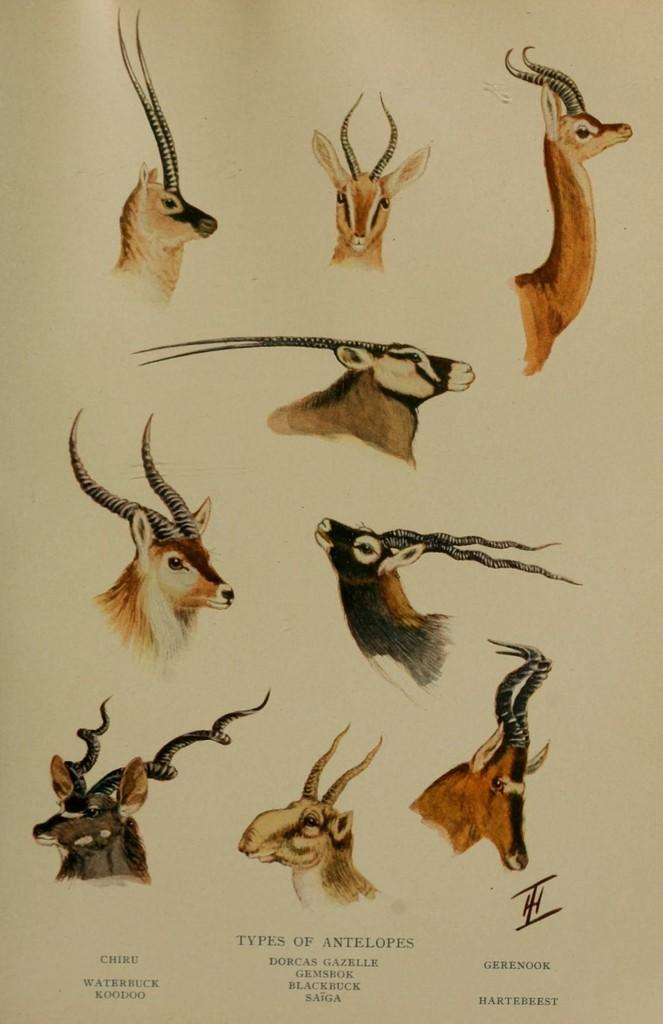What is the main subject of the paper in the image? The paper contains images of different types of antelopes. Is there any text on the paper? Yes, there is text at the bottom of the paper. What type of bead is being used to teach the antelopes in the image? There is no bead present in the image, and the antelopes are not being taught. 